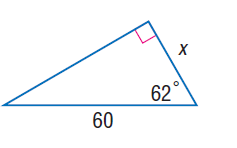Question: Find x.
Choices:
A. 22.1
B. 23.4
C. 26.3
D. 28.2
Answer with the letter. Answer: D 